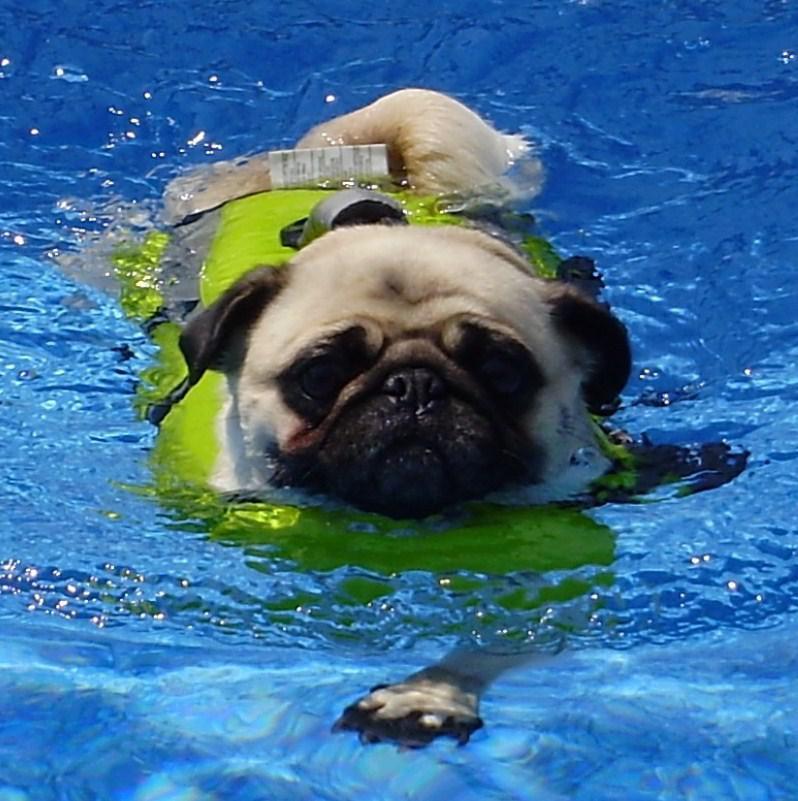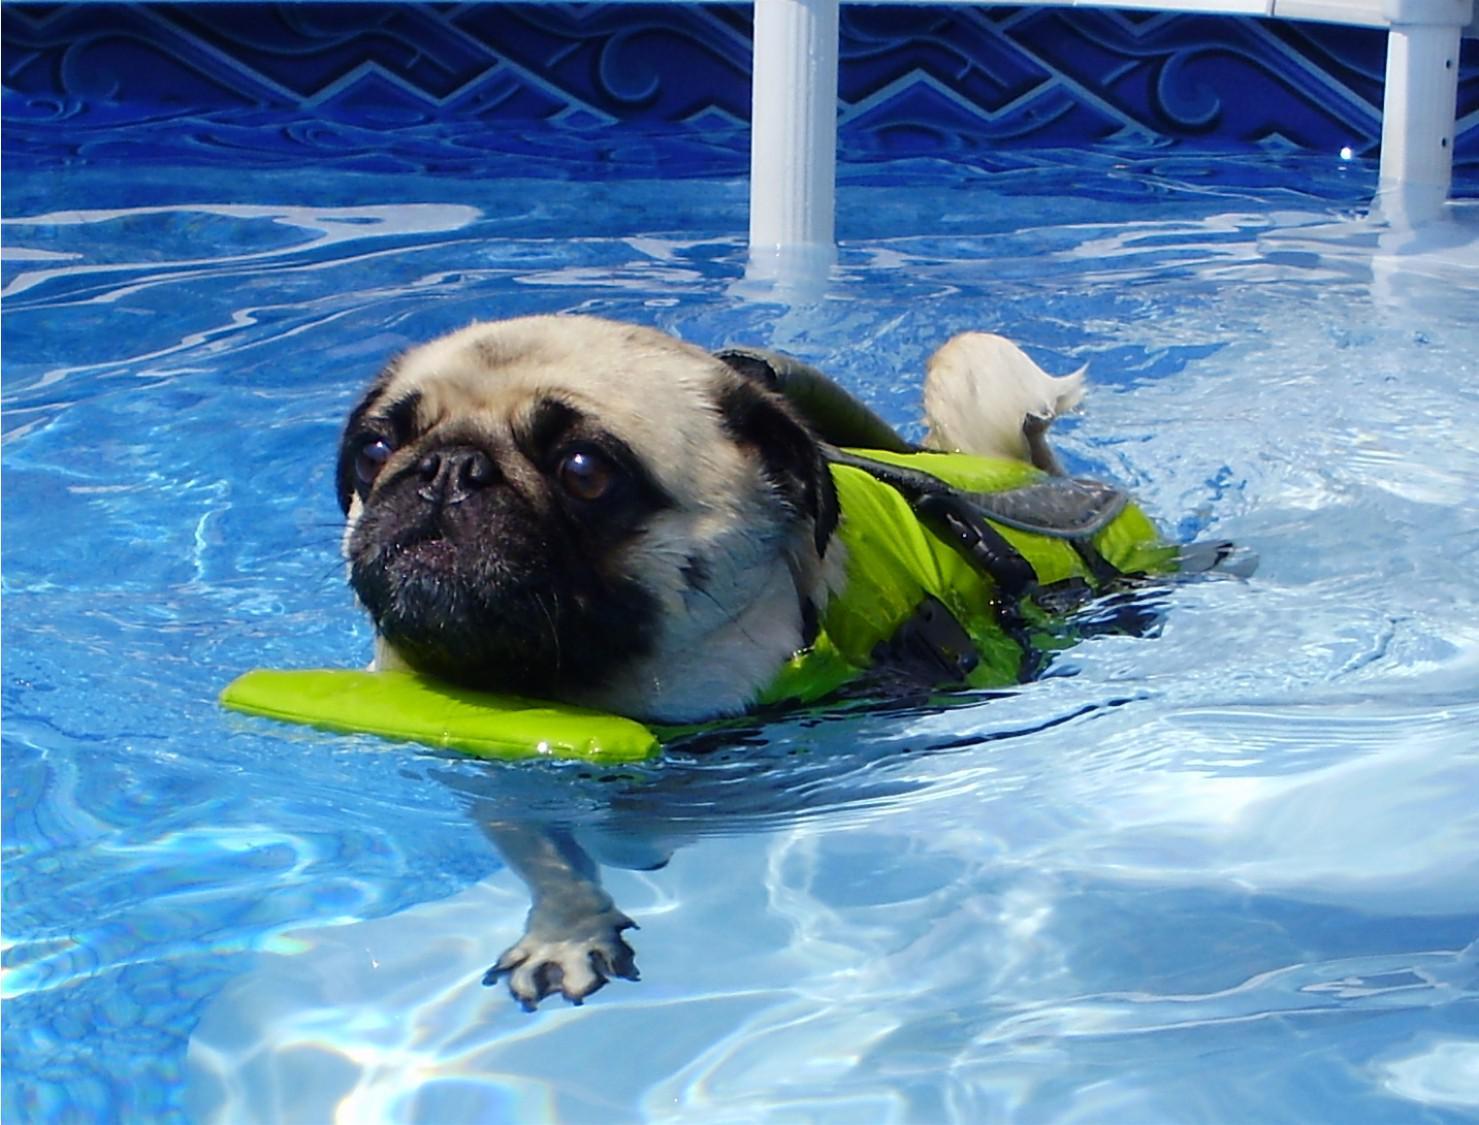The first image is the image on the left, the second image is the image on the right. Considering the images on both sides, is "Two small dogs with pudgy noses and downturned ears are in a swimming pool aided by a floatation device." valid? Answer yes or no. Yes. The first image is the image on the left, the second image is the image on the right. Examine the images to the left and right. Is the description "An image shows a rightward facing dog in a pool with no flotation device." accurate? Answer yes or no. No. 